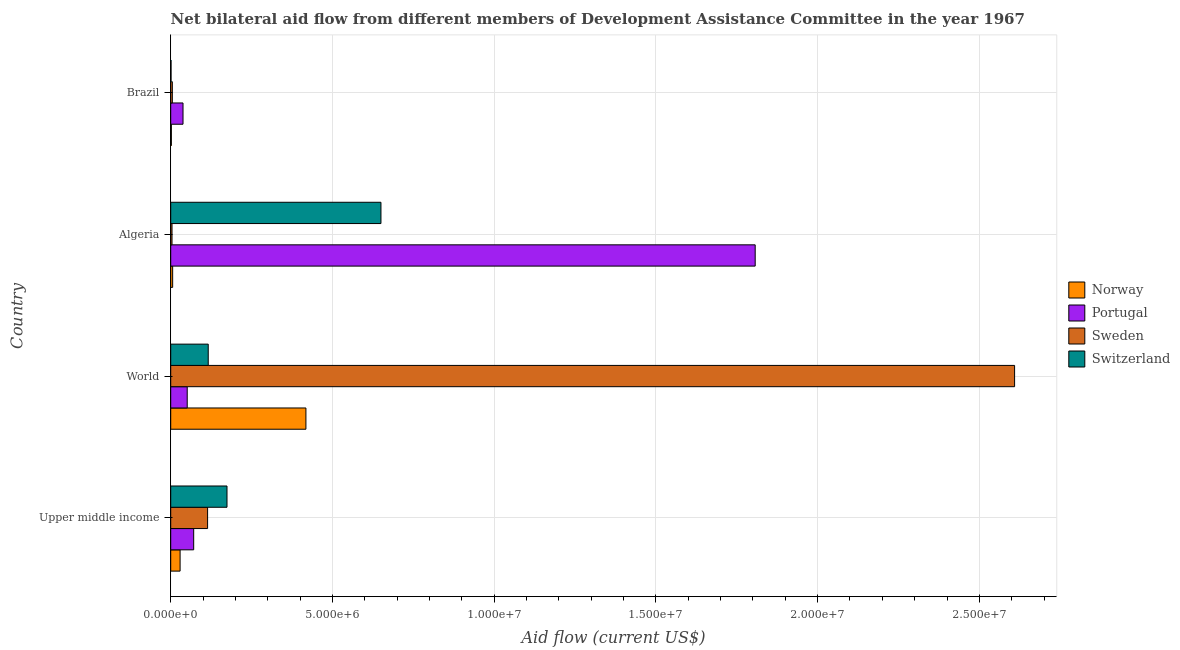How many different coloured bars are there?
Your answer should be compact. 4. How many groups of bars are there?
Your response must be concise. 4. Are the number of bars per tick equal to the number of legend labels?
Your answer should be very brief. Yes. How many bars are there on the 1st tick from the top?
Offer a terse response. 4. How many bars are there on the 2nd tick from the bottom?
Keep it short and to the point. 4. What is the label of the 3rd group of bars from the top?
Provide a succinct answer. World. What is the amount of aid given by sweden in Algeria?
Your answer should be compact. 4.00e+04. Across all countries, what is the maximum amount of aid given by norway?
Ensure brevity in your answer.  4.18e+06. Across all countries, what is the minimum amount of aid given by portugal?
Ensure brevity in your answer.  3.80e+05. In which country was the amount of aid given by sweden minimum?
Provide a succinct answer. Algeria. What is the total amount of aid given by norway in the graph?
Provide a short and direct response. 4.55e+06. What is the difference between the amount of aid given by sweden in Algeria and that in Upper middle income?
Your answer should be compact. -1.10e+06. What is the difference between the amount of aid given by portugal in World and the amount of aid given by sweden in Algeria?
Your response must be concise. 4.70e+05. What is the average amount of aid given by switzerland per country?
Keep it short and to the point. 2.35e+06. What is the difference between the amount of aid given by switzerland and amount of aid given by portugal in Brazil?
Make the answer very short. -3.70e+05. What is the ratio of the amount of aid given by switzerland in Algeria to that in World?
Your response must be concise. 5.6. Is the difference between the amount of aid given by sweden in Algeria and World greater than the difference between the amount of aid given by switzerland in Algeria and World?
Give a very brief answer. No. What is the difference between the highest and the second highest amount of aid given by portugal?
Give a very brief answer. 1.74e+07. What is the difference between the highest and the lowest amount of aid given by sweden?
Your answer should be compact. 2.60e+07. In how many countries, is the amount of aid given by portugal greater than the average amount of aid given by portugal taken over all countries?
Your answer should be compact. 1. Is it the case that in every country, the sum of the amount of aid given by switzerland and amount of aid given by sweden is greater than the sum of amount of aid given by norway and amount of aid given by portugal?
Provide a succinct answer. No. What does the 1st bar from the top in Upper middle income represents?
Give a very brief answer. Switzerland. Are all the bars in the graph horizontal?
Keep it short and to the point. Yes. What is the difference between two consecutive major ticks on the X-axis?
Ensure brevity in your answer.  5.00e+06. Are the values on the major ticks of X-axis written in scientific E-notation?
Provide a succinct answer. Yes. Does the graph contain any zero values?
Provide a short and direct response. No. What is the title of the graph?
Offer a terse response. Net bilateral aid flow from different members of Development Assistance Committee in the year 1967. Does "Tracking ability" appear as one of the legend labels in the graph?
Make the answer very short. No. What is the Aid flow (current US$) in Portugal in Upper middle income?
Keep it short and to the point. 7.10e+05. What is the Aid flow (current US$) of Sweden in Upper middle income?
Offer a terse response. 1.14e+06. What is the Aid flow (current US$) in Switzerland in Upper middle income?
Your response must be concise. 1.74e+06. What is the Aid flow (current US$) of Norway in World?
Offer a very short reply. 4.18e+06. What is the Aid flow (current US$) of Portugal in World?
Ensure brevity in your answer.  5.10e+05. What is the Aid flow (current US$) of Sweden in World?
Provide a succinct answer. 2.61e+07. What is the Aid flow (current US$) in Switzerland in World?
Ensure brevity in your answer.  1.16e+06. What is the Aid flow (current US$) in Portugal in Algeria?
Keep it short and to the point. 1.81e+07. What is the Aid flow (current US$) of Sweden in Algeria?
Make the answer very short. 4.00e+04. What is the Aid flow (current US$) in Switzerland in Algeria?
Provide a short and direct response. 6.50e+06. What is the Aid flow (current US$) in Portugal in Brazil?
Your answer should be very brief. 3.80e+05. What is the Aid flow (current US$) of Sweden in Brazil?
Offer a terse response. 5.00e+04. Across all countries, what is the maximum Aid flow (current US$) in Norway?
Provide a succinct answer. 4.18e+06. Across all countries, what is the maximum Aid flow (current US$) in Portugal?
Offer a terse response. 1.81e+07. Across all countries, what is the maximum Aid flow (current US$) of Sweden?
Offer a terse response. 2.61e+07. Across all countries, what is the maximum Aid flow (current US$) of Switzerland?
Provide a succinct answer. 6.50e+06. Across all countries, what is the minimum Aid flow (current US$) in Sweden?
Give a very brief answer. 4.00e+04. Across all countries, what is the minimum Aid flow (current US$) in Switzerland?
Provide a succinct answer. 10000. What is the total Aid flow (current US$) in Norway in the graph?
Keep it short and to the point. 4.55e+06. What is the total Aid flow (current US$) of Portugal in the graph?
Provide a succinct answer. 1.97e+07. What is the total Aid flow (current US$) in Sweden in the graph?
Keep it short and to the point. 2.73e+07. What is the total Aid flow (current US$) of Switzerland in the graph?
Your answer should be very brief. 9.41e+06. What is the difference between the Aid flow (current US$) of Norway in Upper middle income and that in World?
Provide a succinct answer. -3.89e+06. What is the difference between the Aid flow (current US$) of Sweden in Upper middle income and that in World?
Your answer should be compact. -2.50e+07. What is the difference between the Aid flow (current US$) of Switzerland in Upper middle income and that in World?
Provide a short and direct response. 5.80e+05. What is the difference between the Aid flow (current US$) of Portugal in Upper middle income and that in Algeria?
Offer a terse response. -1.74e+07. What is the difference between the Aid flow (current US$) in Sweden in Upper middle income and that in Algeria?
Provide a short and direct response. 1.10e+06. What is the difference between the Aid flow (current US$) in Switzerland in Upper middle income and that in Algeria?
Provide a short and direct response. -4.76e+06. What is the difference between the Aid flow (current US$) in Portugal in Upper middle income and that in Brazil?
Your answer should be compact. 3.30e+05. What is the difference between the Aid flow (current US$) of Sweden in Upper middle income and that in Brazil?
Offer a very short reply. 1.09e+06. What is the difference between the Aid flow (current US$) in Switzerland in Upper middle income and that in Brazil?
Offer a very short reply. 1.73e+06. What is the difference between the Aid flow (current US$) of Norway in World and that in Algeria?
Make the answer very short. 4.12e+06. What is the difference between the Aid flow (current US$) of Portugal in World and that in Algeria?
Offer a very short reply. -1.76e+07. What is the difference between the Aid flow (current US$) in Sweden in World and that in Algeria?
Your answer should be compact. 2.60e+07. What is the difference between the Aid flow (current US$) of Switzerland in World and that in Algeria?
Keep it short and to the point. -5.34e+06. What is the difference between the Aid flow (current US$) of Norway in World and that in Brazil?
Your response must be concise. 4.16e+06. What is the difference between the Aid flow (current US$) of Portugal in World and that in Brazil?
Your answer should be compact. 1.30e+05. What is the difference between the Aid flow (current US$) in Sweden in World and that in Brazil?
Your response must be concise. 2.60e+07. What is the difference between the Aid flow (current US$) in Switzerland in World and that in Brazil?
Offer a very short reply. 1.15e+06. What is the difference between the Aid flow (current US$) in Norway in Algeria and that in Brazil?
Offer a terse response. 4.00e+04. What is the difference between the Aid flow (current US$) of Portugal in Algeria and that in Brazil?
Keep it short and to the point. 1.77e+07. What is the difference between the Aid flow (current US$) of Switzerland in Algeria and that in Brazil?
Offer a very short reply. 6.49e+06. What is the difference between the Aid flow (current US$) in Norway in Upper middle income and the Aid flow (current US$) in Sweden in World?
Your answer should be very brief. -2.58e+07. What is the difference between the Aid flow (current US$) of Norway in Upper middle income and the Aid flow (current US$) of Switzerland in World?
Provide a short and direct response. -8.70e+05. What is the difference between the Aid flow (current US$) of Portugal in Upper middle income and the Aid flow (current US$) of Sweden in World?
Offer a very short reply. -2.54e+07. What is the difference between the Aid flow (current US$) in Portugal in Upper middle income and the Aid flow (current US$) in Switzerland in World?
Ensure brevity in your answer.  -4.50e+05. What is the difference between the Aid flow (current US$) of Sweden in Upper middle income and the Aid flow (current US$) of Switzerland in World?
Make the answer very short. -2.00e+04. What is the difference between the Aid flow (current US$) in Norway in Upper middle income and the Aid flow (current US$) in Portugal in Algeria?
Offer a terse response. -1.78e+07. What is the difference between the Aid flow (current US$) of Norway in Upper middle income and the Aid flow (current US$) of Switzerland in Algeria?
Your answer should be very brief. -6.21e+06. What is the difference between the Aid flow (current US$) in Portugal in Upper middle income and the Aid flow (current US$) in Sweden in Algeria?
Your response must be concise. 6.70e+05. What is the difference between the Aid flow (current US$) of Portugal in Upper middle income and the Aid flow (current US$) of Switzerland in Algeria?
Give a very brief answer. -5.79e+06. What is the difference between the Aid flow (current US$) in Sweden in Upper middle income and the Aid flow (current US$) in Switzerland in Algeria?
Your answer should be very brief. -5.36e+06. What is the difference between the Aid flow (current US$) in Norway in Upper middle income and the Aid flow (current US$) in Portugal in Brazil?
Keep it short and to the point. -9.00e+04. What is the difference between the Aid flow (current US$) in Norway in Upper middle income and the Aid flow (current US$) in Sweden in Brazil?
Give a very brief answer. 2.40e+05. What is the difference between the Aid flow (current US$) of Norway in Upper middle income and the Aid flow (current US$) of Switzerland in Brazil?
Provide a short and direct response. 2.80e+05. What is the difference between the Aid flow (current US$) in Sweden in Upper middle income and the Aid flow (current US$) in Switzerland in Brazil?
Give a very brief answer. 1.13e+06. What is the difference between the Aid flow (current US$) of Norway in World and the Aid flow (current US$) of Portugal in Algeria?
Your answer should be very brief. -1.39e+07. What is the difference between the Aid flow (current US$) in Norway in World and the Aid flow (current US$) in Sweden in Algeria?
Make the answer very short. 4.14e+06. What is the difference between the Aid flow (current US$) in Norway in World and the Aid flow (current US$) in Switzerland in Algeria?
Your answer should be very brief. -2.32e+06. What is the difference between the Aid flow (current US$) in Portugal in World and the Aid flow (current US$) in Sweden in Algeria?
Your answer should be very brief. 4.70e+05. What is the difference between the Aid flow (current US$) in Portugal in World and the Aid flow (current US$) in Switzerland in Algeria?
Make the answer very short. -5.99e+06. What is the difference between the Aid flow (current US$) in Sweden in World and the Aid flow (current US$) in Switzerland in Algeria?
Your answer should be very brief. 1.96e+07. What is the difference between the Aid flow (current US$) of Norway in World and the Aid flow (current US$) of Portugal in Brazil?
Ensure brevity in your answer.  3.80e+06. What is the difference between the Aid flow (current US$) of Norway in World and the Aid flow (current US$) of Sweden in Brazil?
Make the answer very short. 4.13e+06. What is the difference between the Aid flow (current US$) of Norway in World and the Aid flow (current US$) of Switzerland in Brazil?
Your answer should be compact. 4.17e+06. What is the difference between the Aid flow (current US$) in Portugal in World and the Aid flow (current US$) in Sweden in Brazil?
Provide a succinct answer. 4.60e+05. What is the difference between the Aid flow (current US$) in Portugal in World and the Aid flow (current US$) in Switzerland in Brazil?
Offer a very short reply. 5.00e+05. What is the difference between the Aid flow (current US$) in Sweden in World and the Aid flow (current US$) in Switzerland in Brazil?
Provide a succinct answer. 2.61e+07. What is the difference between the Aid flow (current US$) of Norway in Algeria and the Aid flow (current US$) of Portugal in Brazil?
Provide a succinct answer. -3.20e+05. What is the difference between the Aid flow (current US$) in Portugal in Algeria and the Aid flow (current US$) in Sweden in Brazil?
Your response must be concise. 1.80e+07. What is the difference between the Aid flow (current US$) in Portugal in Algeria and the Aid flow (current US$) in Switzerland in Brazil?
Make the answer very short. 1.81e+07. What is the difference between the Aid flow (current US$) of Sweden in Algeria and the Aid flow (current US$) of Switzerland in Brazil?
Your answer should be very brief. 3.00e+04. What is the average Aid flow (current US$) in Norway per country?
Offer a terse response. 1.14e+06. What is the average Aid flow (current US$) in Portugal per country?
Offer a terse response. 4.92e+06. What is the average Aid flow (current US$) of Sweden per country?
Give a very brief answer. 6.83e+06. What is the average Aid flow (current US$) of Switzerland per country?
Make the answer very short. 2.35e+06. What is the difference between the Aid flow (current US$) of Norway and Aid flow (current US$) of Portugal in Upper middle income?
Provide a short and direct response. -4.20e+05. What is the difference between the Aid flow (current US$) in Norway and Aid flow (current US$) in Sweden in Upper middle income?
Give a very brief answer. -8.50e+05. What is the difference between the Aid flow (current US$) of Norway and Aid flow (current US$) of Switzerland in Upper middle income?
Provide a succinct answer. -1.45e+06. What is the difference between the Aid flow (current US$) in Portugal and Aid flow (current US$) in Sweden in Upper middle income?
Ensure brevity in your answer.  -4.30e+05. What is the difference between the Aid flow (current US$) of Portugal and Aid flow (current US$) of Switzerland in Upper middle income?
Provide a short and direct response. -1.03e+06. What is the difference between the Aid flow (current US$) of Sweden and Aid flow (current US$) of Switzerland in Upper middle income?
Your answer should be compact. -6.00e+05. What is the difference between the Aid flow (current US$) in Norway and Aid flow (current US$) in Portugal in World?
Your answer should be very brief. 3.67e+06. What is the difference between the Aid flow (current US$) in Norway and Aid flow (current US$) in Sweden in World?
Your response must be concise. -2.19e+07. What is the difference between the Aid flow (current US$) in Norway and Aid flow (current US$) in Switzerland in World?
Ensure brevity in your answer.  3.02e+06. What is the difference between the Aid flow (current US$) of Portugal and Aid flow (current US$) of Sweden in World?
Your answer should be very brief. -2.56e+07. What is the difference between the Aid flow (current US$) in Portugal and Aid flow (current US$) in Switzerland in World?
Ensure brevity in your answer.  -6.50e+05. What is the difference between the Aid flow (current US$) in Sweden and Aid flow (current US$) in Switzerland in World?
Make the answer very short. 2.49e+07. What is the difference between the Aid flow (current US$) of Norway and Aid flow (current US$) of Portugal in Algeria?
Your answer should be very brief. -1.80e+07. What is the difference between the Aid flow (current US$) in Norway and Aid flow (current US$) in Switzerland in Algeria?
Make the answer very short. -6.44e+06. What is the difference between the Aid flow (current US$) of Portugal and Aid flow (current US$) of Sweden in Algeria?
Keep it short and to the point. 1.80e+07. What is the difference between the Aid flow (current US$) in Portugal and Aid flow (current US$) in Switzerland in Algeria?
Offer a terse response. 1.16e+07. What is the difference between the Aid flow (current US$) of Sweden and Aid flow (current US$) of Switzerland in Algeria?
Offer a terse response. -6.46e+06. What is the difference between the Aid flow (current US$) of Norway and Aid flow (current US$) of Portugal in Brazil?
Ensure brevity in your answer.  -3.60e+05. What is the difference between the Aid flow (current US$) in Norway and Aid flow (current US$) in Switzerland in Brazil?
Keep it short and to the point. 10000. What is the difference between the Aid flow (current US$) of Portugal and Aid flow (current US$) of Sweden in Brazil?
Keep it short and to the point. 3.30e+05. What is the difference between the Aid flow (current US$) of Sweden and Aid flow (current US$) of Switzerland in Brazil?
Give a very brief answer. 4.00e+04. What is the ratio of the Aid flow (current US$) in Norway in Upper middle income to that in World?
Keep it short and to the point. 0.07. What is the ratio of the Aid flow (current US$) of Portugal in Upper middle income to that in World?
Your answer should be very brief. 1.39. What is the ratio of the Aid flow (current US$) in Sweden in Upper middle income to that in World?
Ensure brevity in your answer.  0.04. What is the ratio of the Aid flow (current US$) in Switzerland in Upper middle income to that in World?
Ensure brevity in your answer.  1.5. What is the ratio of the Aid flow (current US$) of Norway in Upper middle income to that in Algeria?
Provide a short and direct response. 4.83. What is the ratio of the Aid flow (current US$) in Portugal in Upper middle income to that in Algeria?
Make the answer very short. 0.04. What is the ratio of the Aid flow (current US$) in Switzerland in Upper middle income to that in Algeria?
Keep it short and to the point. 0.27. What is the ratio of the Aid flow (current US$) of Portugal in Upper middle income to that in Brazil?
Your response must be concise. 1.87. What is the ratio of the Aid flow (current US$) in Sweden in Upper middle income to that in Brazil?
Ensure brevity in your answer.  22.8. What is the ratio of the Aid flow (current US$) in Switzerland in Upper middle income to that in Brazil?
Keep it short and to the point. 174. What is the ratio of the Aid flow (current US$) of Norway in World to that in Algeria?
Offer a very short reply. 69.67. What is the ratio of the Aid flow (current US$) of Portugal in World to that in Algeria?
Your answer should be compact. 0.03. What is the ratio of the Aid flow (current US$) in Sweden in World to that in Algeria?
Your response must be concise. 652.25. What is the ratio of the Aid flow (current US$) of Switzerland in World to that in Algeria?
Provide a short and direct response. 0.18. What is the ratio of the Aid flow (current US$) of Norway in World to that in Brazil?
Your response must be concise. 209. What is the ratio of the Aid flow (current US$) of Portugal in World to that in Brazil?
Provide a succinct answer. 1.34. What is the ratio of the Aid flow (current US$) of Sweden in World to that in Brazil?
Offer a terse response. 521.8. What is the ratio of the Aid flow (current US$) in Switzerland in World to that in Brazil?
Provide a short and direct response. 116. What is the ratio of the Aid flow (current US$) in Norway in Algeria to that in Brazil?
Give a very brief answer. 3. What is the ratio of the Aid flow (current US$) of Portugal in Algeria to that in Brazil?
Make the answer very short. 47.55. What is the ratio of the Aid flow (current US$) of Switzerland in Algeria to that in Brazil?
Give a very brief answer. 650. What is the difference between the highest and the second highest Aid flow (current US$) in Norway?
Give a very brief answer. 3.89e+06. What is the difference between the highest and the second highest Aid flow (current US$) of Portugal?
Give a very brief answer. 1.74e+07. What is the difference between the highest and the second highest Aid flow (current US$) in Sweden?
Ensure brevity in your answer.  2.50e+07. What is the difference between the highest and the second highest Aid flow (current US$) of Switzerland?
Your response must be concise. 4.76e+06. What is the difference between the highest and the lowest Aid flow (current US$) in Norway?
Offer a terse response. 4.16e+06. What is the difference between the highest and the lowest Aid flow (current US$) of Portugal?
Your answer should be very brief. 1.77e+07. What is the difference between the highest and the lowest Aid flow (current US$) of Sweden?
Give a very brief answer. 2.60e+07. What is the difference between the highest and the lowest Aid flow (current US$) of Switzerland?
Offer a very short reply. 6.49e+06. 